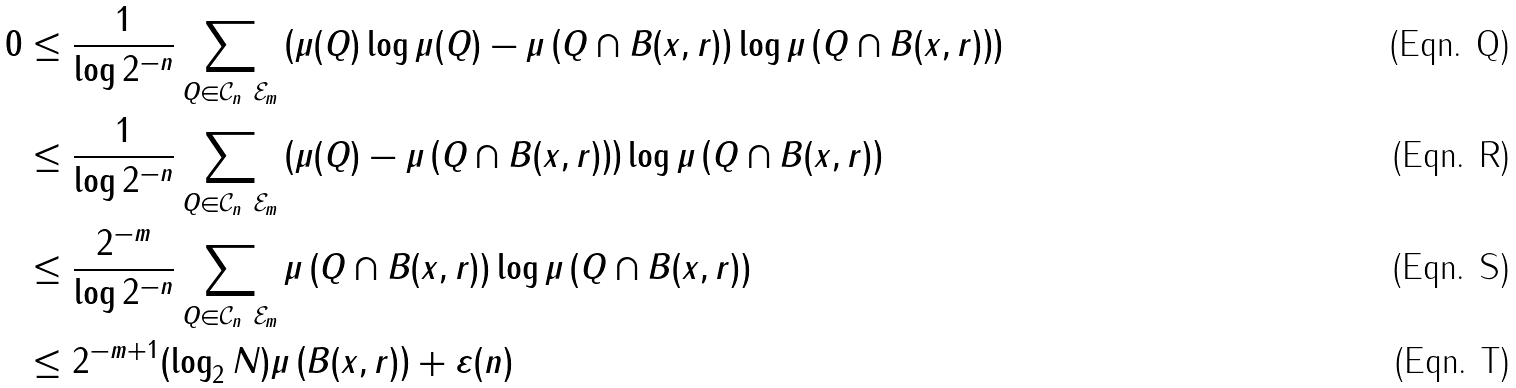<formula> <loc_0><loc_0><loc_500><loc_500>0 & \leq \frac { 1 } { \log { 2 ^ { - n } } } \sum _ { Q \in \mathcal { C } _ { n } \ \mathcal { E } _ { m } } \left ( \mu ( Q ) \log \mu ( Q ) - \mu \left ( Q \cap B ( x , r ) \right ) \log \mu \left ( Q \cap B ( x , r ) \right ) \right ) \\ & \leq \frac { 1 } { \log { 2 ^ { - n } } } \sum _ { Q \in \mathcal { C } _ { n } \ \mathcal { E } _ { m } } \left ( \mu ( Q ) - \mu \left ( Q \cap B ( x , r ) \right ) \right ) \log \mu \left ( Q \cap B ( x , r ) \right ) \\ & \leq \frac { 2 ^ { - m } } { \log { 2 ^ { - n } } } \sum _ { Q \in \mathcal { C } _ { n } \ \mathcal { E } _ { m } } \mu \left ( Q \cap B ( x , r ) \right ) \log \mu \left ( Q \cap B ( x , r ) \right ) \\ & \leq 2 ^ { - m + 1 } ( \log _ { 2 } N ) \mu \left ( B ( x , r ) \right ) + \varepsilon ( n )</formula> 